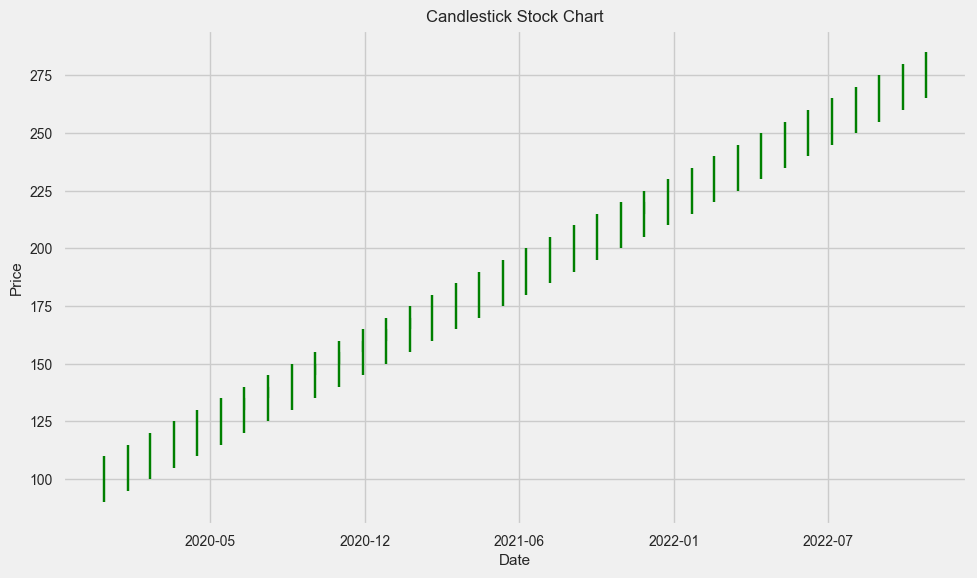What is the overall trend of the stock price from January 2020 to December 2022? The stock price shows an overall increasing trend. This can be observed by noticing that the opening price in January 2020 is much lower than the closing price in December 2022, with a steady rise throughout the period.
Answer: Increasing trend Between which months did the stock price increase the most? By visually inspecting the lengths of the candlesticks, the largest jump seems to occur between January 2022 and February 2022, where the closing price moved significantly higher from 220 to 230.
Answer: January 2022 and February 2022 Which month has the highest trading volume, and what is the corresponding stock price at the close? The month with the highest trading volume is December 2022, and the corresponding stock price at the close for that month is 280. This can be seen by noticing the highest "Volume" value and finding the corresponding "Close" price.
Answer: December 2022, 280 What is the average closing price for the year 2021? To find the average closing price for 2021, sum the closing prices from January to December 2021 (165, 170, 175, 180, 185, 190, 195, 200, 205, 210, 215, 220) and divide by 12. The calculation is (165 + 170 + 175 + 180 + 185 + 190 + 195 + 200 + 205 + 210 + 215 + 220) / 12 = 192.92
Answer: 192.92 How does the opening price in January 2020 compare to the closing price in December 2022? The opening price in January 2020 is 100, and the closing price in December 2022 is 280. The comparison shows that the closing price in December 2022 is much higher than the opening price in January 2020.
Answer: Closing price in December 2022 is much higher Which months have red candlesticks, indicating a decrease in price from open to close? Red candlesticks appear where the closing price is lower than the opening price. By checking each candlestick, there are no months in the provided data with red candlesticks between January 2020 and December 2022.
Answer: None What is the range (difference) between the highest and lowest prices recorded in 2020? The highest price recorded in 2020 is 165 in December, and the lowest price recorded is 90 in January. The range can be calculated by subtracting the lowest price from the highest price: 165 - 90 = 75
Answer: 75 Between which months in 2021 did the stock experience the smallest increase? By visually inspecting the candlesticks for each month in 2021, the smallest increase appears between April 2021 and May 2021, where both the opening and closing prices (175 to 185) show minimal incremental change compared to other months.
Answer: April 2021 and May 2021 